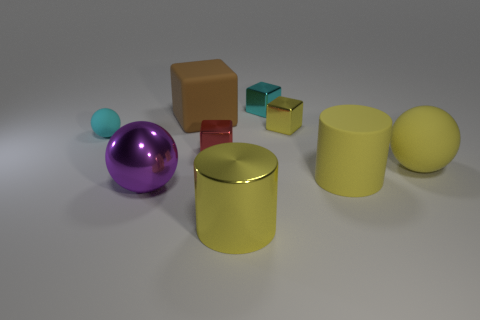Is there a yellow rubber sphere of the same size as the yellow shiny cylinder?
Your answer should be very brief. Yes. There is a small cyan object on the left side of the big brown rubber cube; what is its material?
Ensure brevity in your answer.  Rubber. Is the cyan cube that is on the right side of the brown rubber object made of the same material as the large purple ball?
Your answer should be very brief. Yes. There is a purple metal thing that is the same size as the yellow matte cylinder; what shape is it?
Give a very brief answer. Sphere. What number of large cubes are the same color as the large metal sphere?
Your answer should be compact. 0. Are there fewer tiny shiny cubes behind the cyan ball than small cyan objects in front of the purple thing?
Your answer should be very brief. No. Are there any matte cubes in front of the large purple metallic ball?
Give a very brief answer. No. Is there a red thing right of the large cylinder that is behind the large cylinder on the left side of the cyan metallic thing?
Ensure brevity in your answer.  No. There is a small matte object that is left of the big yellow matte cylinder; is it the same shape as the large purple object?
Provide a short and direct response. Yes. The cylinder that is the same material as the tiny red object is what color?
Make the answer very short. Yellow. 